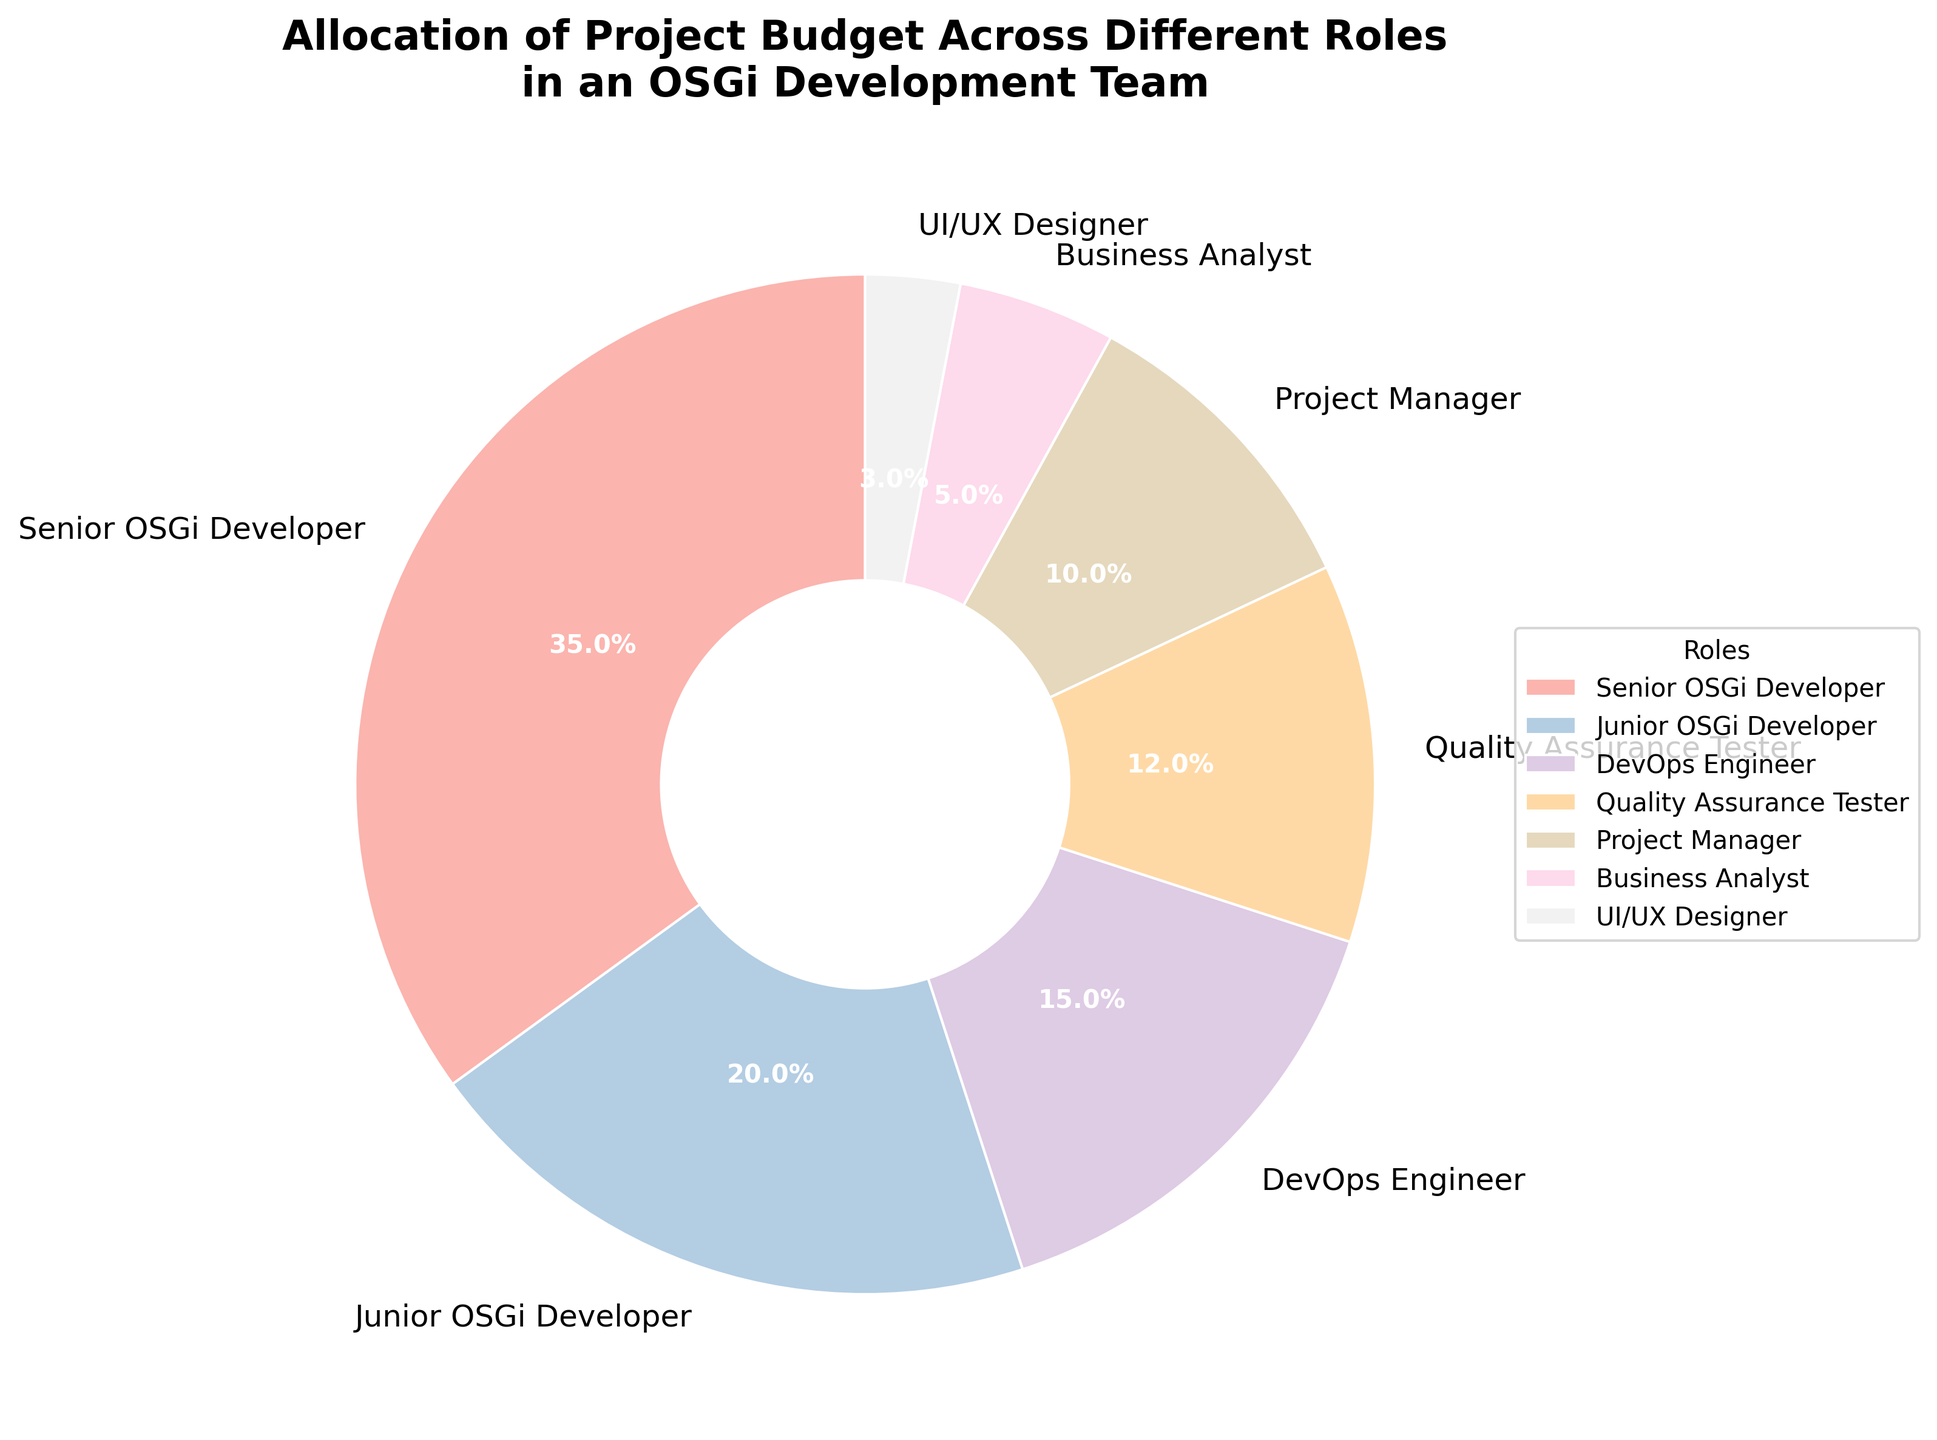What percentage of the budget is allocated to the roles related to OSGi development? We need to sum the percentages allocated to the Senior OSGi Developer and Junior OSGi Developer. These values are 35% and 20%, respectively. Adding them together gives 35% + 20% = 55%.
Answer: 55% How does the budget allocated to the Senior OSGi Developer compare to that for the DevOps Engineer? The budget for the Senior OSGi Developer is 35%, while that for the DevOps Engineer is 15%. 35% is greater than 15%.
Answer: Senior OSGi Developer has more What is the total budget percentage allocated to roles other than OSGi Developers and DevOps Engineers? Summing the percentages of Quality Assurance Tester, Project Manager, Business Analyst, and UI/UX Designer: 12% + 10% + 5% + 3% = 30%.
Answer: 30% Which role has the smallest budget allocation, and what is the percentage? By comparing the percentages, the UI/UX Designer has the smallest budget allocation at 3%.
Answer: UI/UX Designer, 3% What is the difference in budget allocation between the Project Manager and the Business Analyst? The Project Manager has a budget allocation of 10%, and the Business Analyst has 5%. The difference is 10% - 5% = 5%.
Answer: 5% Which role combination, Junior OSGi Developer and DevOps Engineer or Quality Assurance Tester and Project Manager, has a higher total budget allocation? Summing the percentages: Junior OSGi Developer (20%) + DevOps Engineer (15%) = 35%; Quality Assurance Tester (12%) + Project Manager (10%) = 22%. 35% is greater than 22%.
Answer: Junior OSGi Developer and DevOps Engineer Of the roles related to management (Project Manager and Business Analyst), which one has a higher budget allocation? The Project Manager has 10% and the Business Analyst has 5%. 10% is greater than 5%.
Answer: Project Manager What is the sum of the budget percentages allocated to the Junior OSGi Developer, Quality Assurance Tester, and UI/UX Designer? Adding the percentages: Junior OSGi Developer (20%) + Quality Assurance Tester (12%) + UI/UX Designer (3%) = 35%.
Answer: 35% Comparing the roles in the figure, how does the budget allocation for a DevOps Engineer rank? The DevOps Engineer has a budget allocation of 15%, ranking it third after the Senior OSGi Developer (35%) and Junior OSGi Developer (20%).
Answer: Third What visual attribute distinguishes the different roles in the pie chart? The different roles are distinguished by the use of varying colors for each wedge in the pie chart.
Answer: Colors 